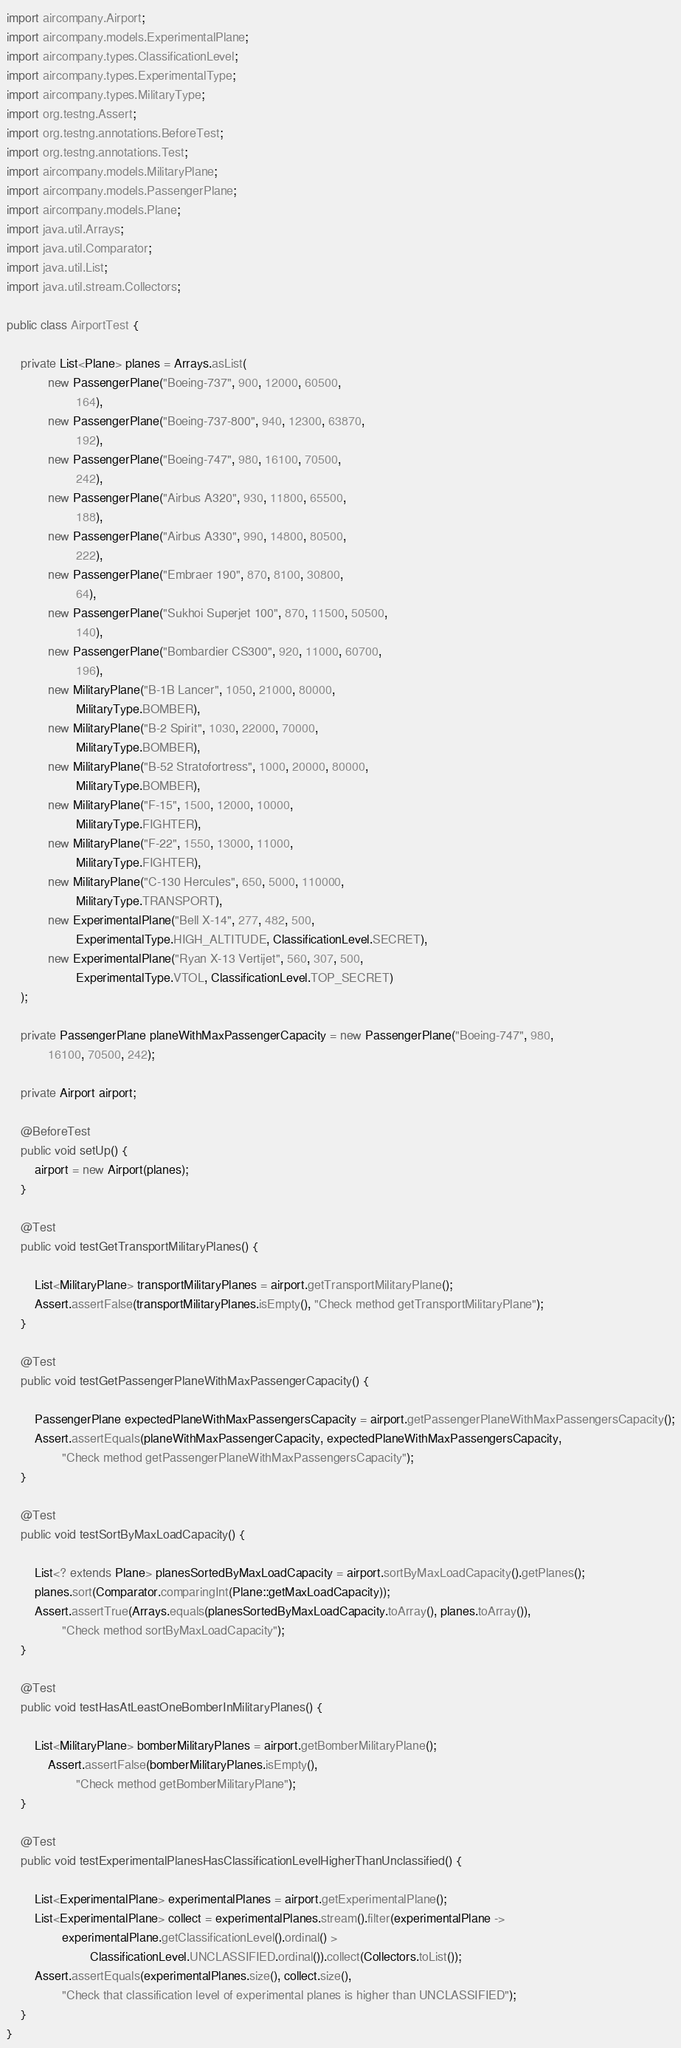<code> <loc_0><loc_0><loc_500><loc_500><_Java_>import aircompany.Airport;
import aircompany.models.ExperimentalPlane;
import aircompany.types.ClassificationLevel;
import aircompany.types.ExperimentalType;
import aircompany.types.MilitaryType;
import org.testng.Assert;
import org.testng.annotations.BeforeTest;
import org.testng.annotations.Test;
import aircompany.models.MilitaryPlane;
import aircompany.models.PassengerPlane;
import aircompany.models.Plane;
import java.util.Arrays;
import java.util.Comparator;
import java.util.List;
import java.util.stream.Collectors;

public class AirportTest {

    private List<Plane> planes = Arrays.asList(
            new PassengerPlane("Boeing-737", 900, 12000, 60500,
                    164),
            new PassengerPlane("Boeing-737-800", 940, 12300, 63870,
                    192),
            new PassengerPlane("Boeing-747", 980, 16100, 70500,
                    242),
            new PassengerPlane("Airbus A320", 930, 11800, 65500,
                    188),
            new PassengerPlane("Airbus A330", 990, 14800, 80500,
                    222),
            new PassengerPlane("Embraer 190", 870, 8100, 30800,
                    64),
            new PassengerPlane("Sukhoi Superjet 100", 870, 11500, 50500,
                    140),
            new PassengerPlane("Bombardier CS300", 920, 11000, 60700,
                    196),
            new MilitaryPlane("B-1B Lancer", 1050, 21000, 80000,
                    MilitaryType.BOMBER),
            new MilitaryPlane("B-2 Spirit", 1030, 22000, 70000,
                    MilitaryType.BOMBER),
            new MilitaryPlane("B-52 Stratofortress", 1000, 20000, 80000,
                    MilitaryType.BOMBER),
            new MilitaryPlane("F-15", 1500, 12000, 10000,
                    MilitaryType.FIGHTER),
            new MilitaryPlane("F-22", 1550, 13000, 11000,
                    MilitaryType.FIGHTER),
            new MilitaryPlane("C-130 Hercules", 650, 5000, 110000,
                    MilitaryType.TRANSPORT),
            new ExperimentalPlane("Bell X-14", 277, 482, 500,
                    ExperimentalType.HIGH_ALTITUDE, ClassificationLevel.SECRET),
            new ExperimentalPlane("Ryan X-13 Vertijet", 560, 307, 500,
                    ExperimentalType.VTOL, ClassificationLevel.TOP_SECRET)
    );

    private PassengerPlane planeWithMaxPassengerCapacity = new PassengerPlane("Boeing-747", 980,
            16100, 70500, 242);

    private Airport airport;

    @BeforeTest
    public void setUp() {
        airport = new Airport(planes);
    }

    @Test
    public void testGetTransportMilitaryPlanes() {

        List<MilitaryPlane> transportMilitaryPlanes = airport.getTransportMilitaryPlane();
        Assert.assertFalse(transportMilitaryPlanes.isEmpty(), "Check method getTransportMilitaryPlane");
    }

    @Test
    public void testGetPassengerPlaneWithMaxPassengerCapacity() {

        PassengerPlane expectedPlaneWithMaxPassengersCapacity = airport.getPassengerPlaneWithMaxPassengersCapacity();
        Assert.assertEquals(planeWithMaxPassengerCapacity, expectedPlaneWithMaxPassengersCapacity,
                "Check method getPassengerPlaneWithMaxPassengersCapacity");
    }

    @Test
    public void testSortByMaxLoadCapacity() {

        List<? extends Plane> planesSortedByMaxLoadCapacity = airport.sortByMaxLoadCapacity().getPlanes();
        planes.sort(Comparator.comparingInt(Plane::getMaxLoadCapacity));
        Assert.assertTrue(Arrays.equals(planesSortedByMaxLoadCapacity.toArray(), planes.toArray()),
                "Check method sortByMaxLoadCapacity");
    }

    @Test
    public void testHasAtLeastOneBomberInMilitaryPlanes() {

        List<MilitaryPlane> bomberMilitaryPlanes = airport.getBomberMilitaryPlane();
            Assert.assertFalse(bomberMilitaryPlanes.isEmpty(),
                    "Check method getBomberMilitaryPlane");
    }

    @Test
    public void testExperimentalPlanesHasClassificationLevelHigherThanUnclassified() {

        List<ExperimentalPlane> experimentalPlanes = airport.getExperimentalPlane();
        List<ExperimentalPlane> collect = experimentalPlanes.stream().filter(experimentalPlane ->
                experimentalPlane.getClassificationLevel().ordinal() >
                        ClassificationLevel.UNCLASSIFIED.ordinal()).collect(Collectors.toList());
        Assert.assertEquals(experimentalPlanes.size(), collect.size(),
                "Check that classification level of experimental planes is higher than UNCLASSIFIED");
    }
}</code> 